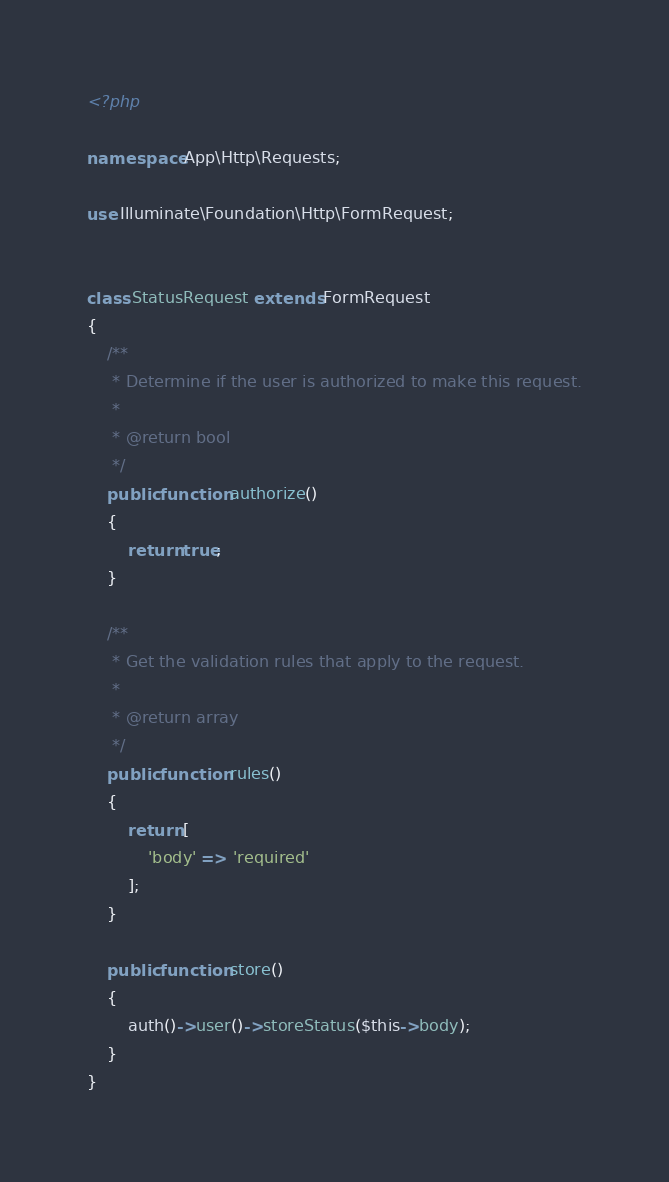<code> <loc_0><loc_0><loc_500><loc_500><_PHP_><?php

namespace App\Http\Requests;

use Illuminate\Foundation\Http\FormRequest;


class StatusRequest extends FormRequest
{
    /**
     * Determine if the user is authorized to make this request.
     *
     * @return bool
     */
    public function authorize()
    {
        return true;
    }

    /**
     * Get the validation rules that apply to the request.
     *
     * @return array
     */
    public function rules()
    {
        return [
            'body' => 'required'
        ];
    }

    public function store()
    {
        auth()->user()->storeStatus($this->body);
    }
}
</code> 